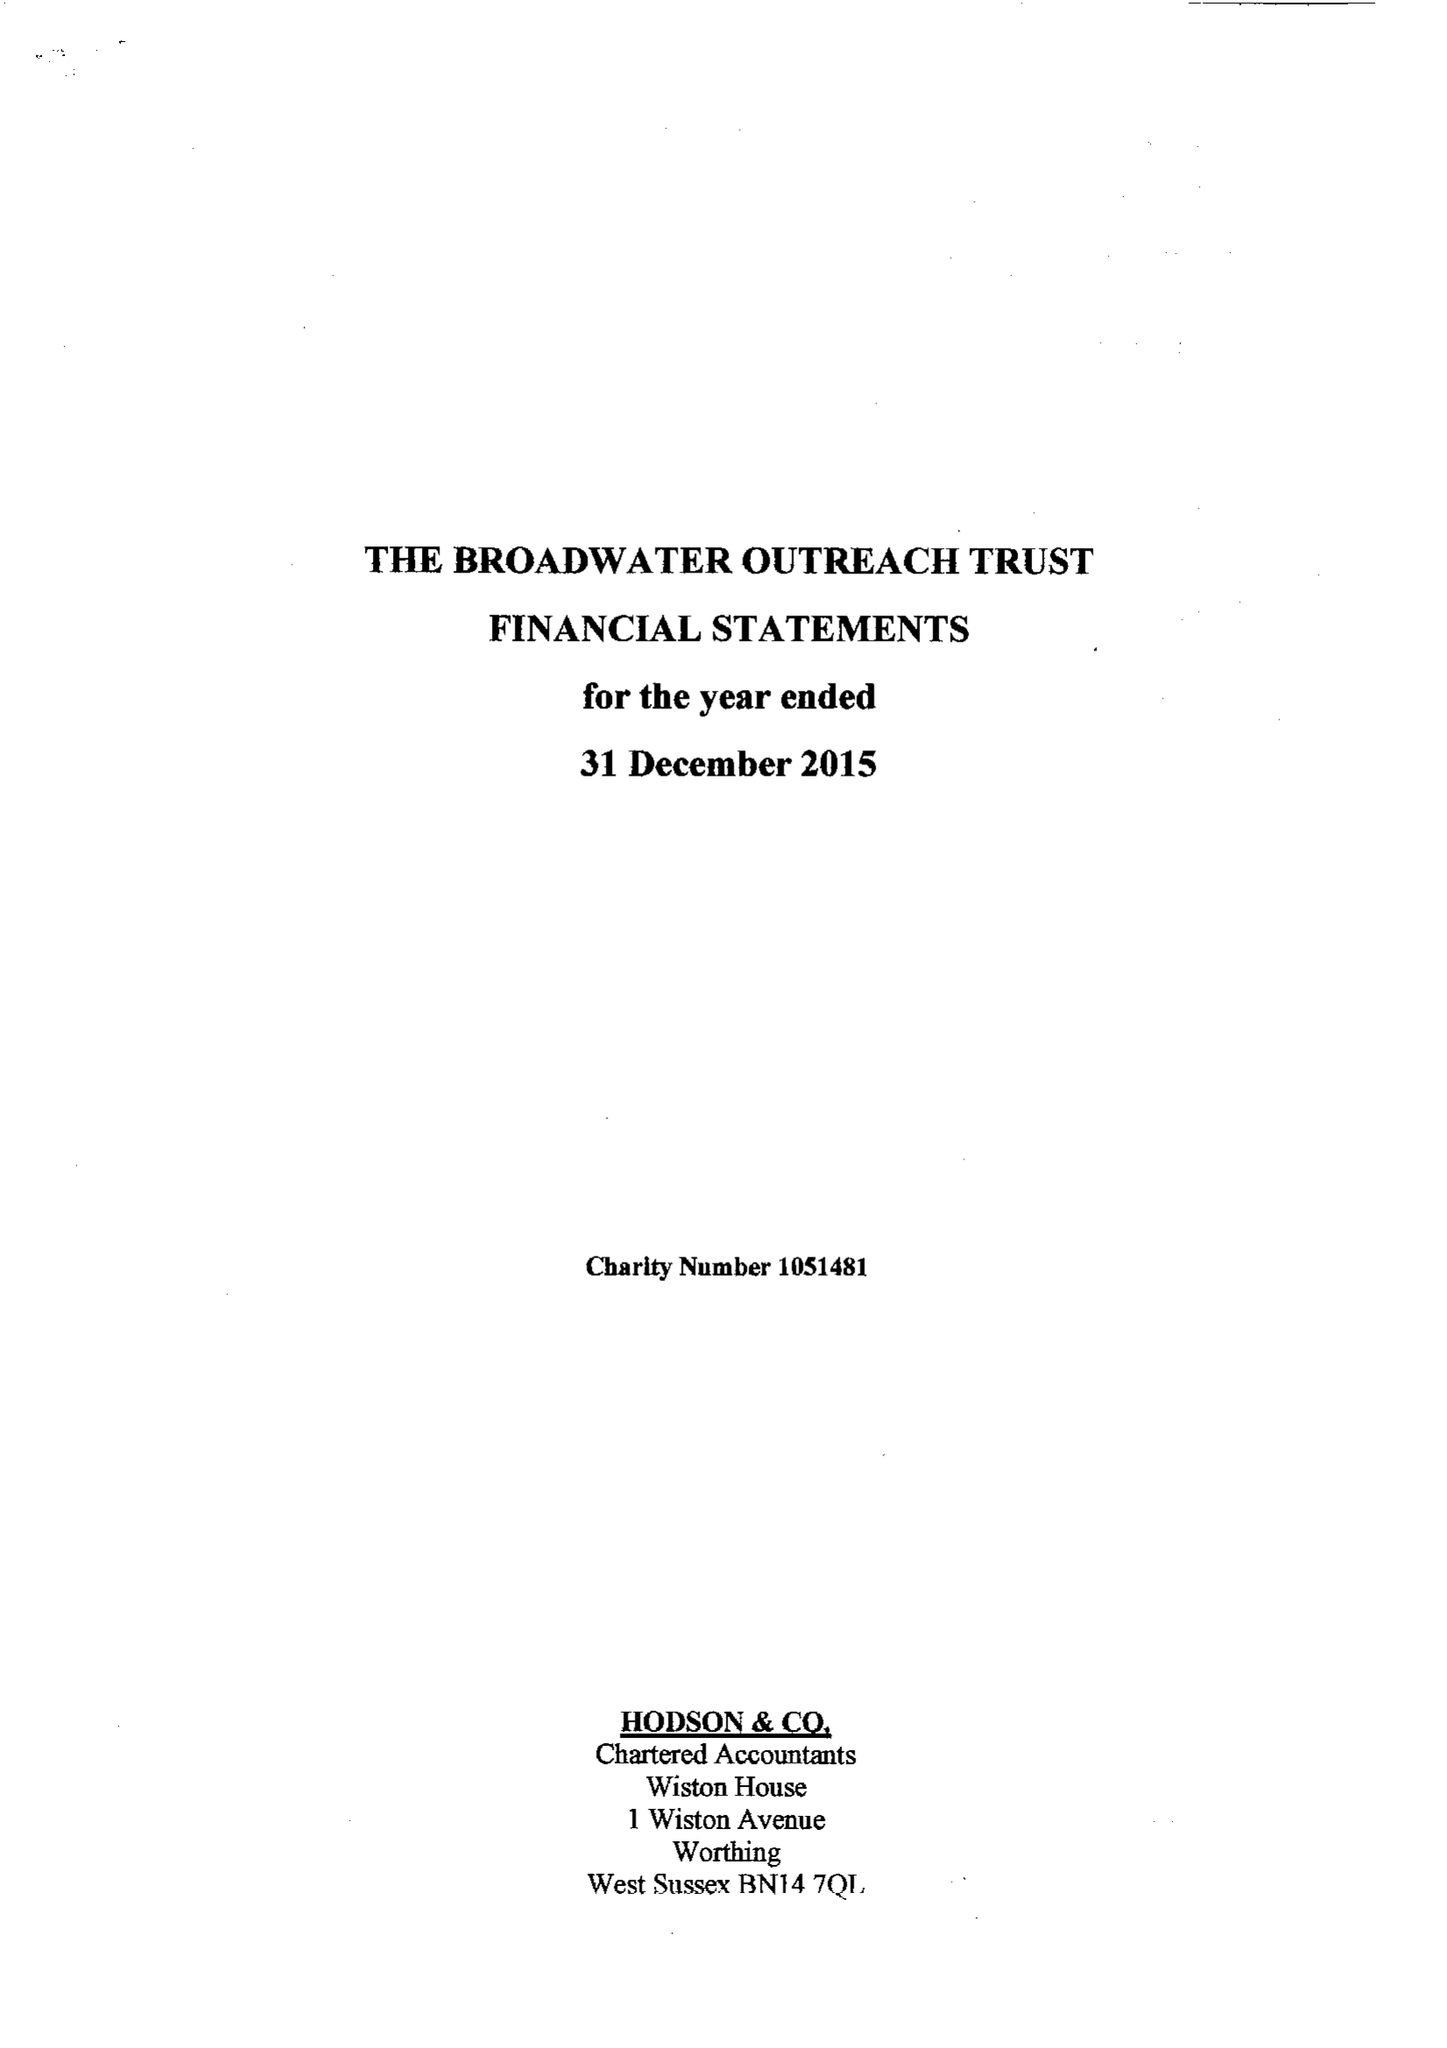What is the value for the income_annually_in_british_pounds?
Answer the question using a single word or phrase. 26322.00 